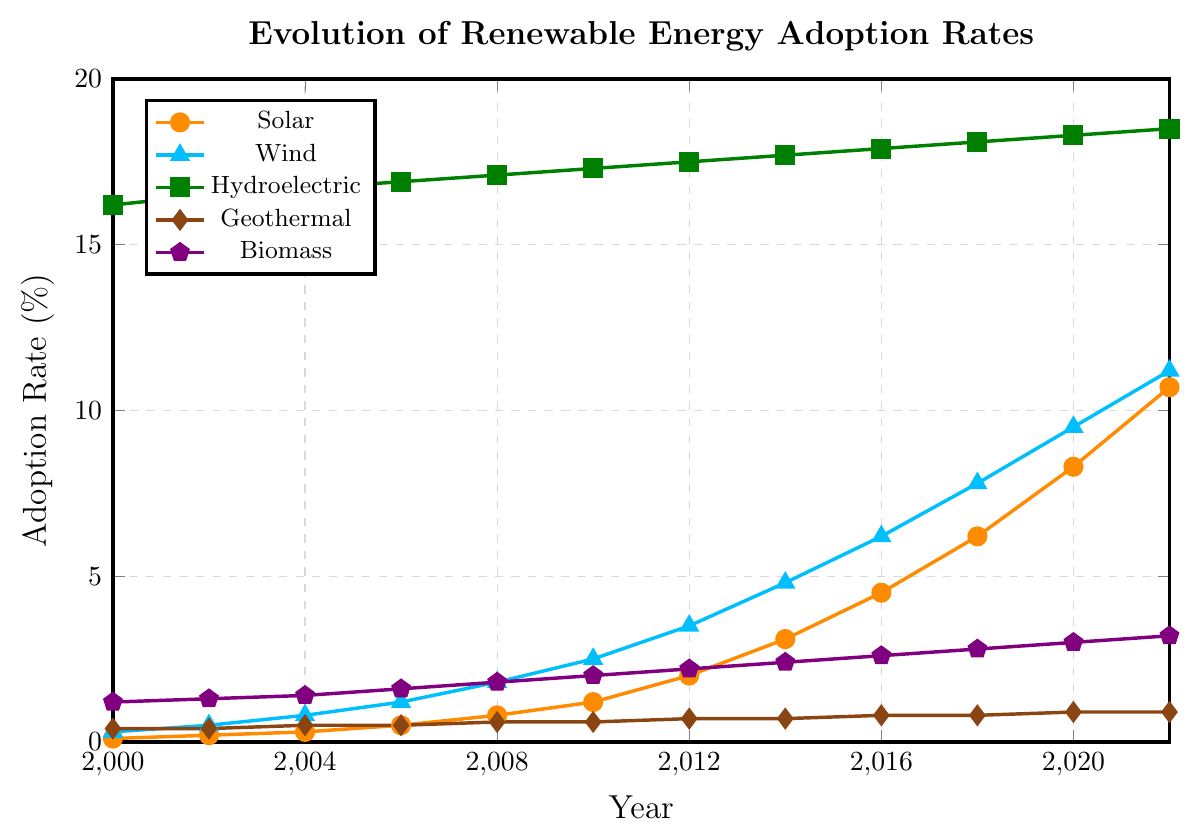What energy type had the highest adoption rate in the year 2022? Looking at the figure, the curve representing hydroelectric energy adoption is the highest among all the curves, surpassing solar, wind, geothermal, and biomass in the year 2022.
Answer: Hydroelectric What is the difference in adoption rate between solar and wind energy in 2020? From the figure, solar energy adoption in 2020 is 8.3%, and wind energy adoption is 9.5%. Subtracting the adoption rate of solar from wind gives 9.5% - 8.3% = 1.2%.
Answer: 1.2% Which energy type shows the most significant increase in adoption rate from 2000 to 2022? By comparing the curves from 2000 to 2022, the solar energy adoption rate increased from 0.1% to 10.7%, which is the most significant increase compared to the other energy types whose increases are proportionally smaller.
Answer: Solar How does the adoption rate of wind energy in 2016 compare to biomass energy in the same year? In 2016, the wind energy adoption rate is observed to be 6.2%, whereas biomass energy adoption is 2.6%. Therefore, wind energy adoption is higher than biomass energy adoption.
Answer: Wind energy is higher What is the average adoption rate of hydroelectric energy from 2000 to 2022? Examining the figure, the adoption rates of hydroelectric energy are (16.2, 16.5, 16.7, 16.9, 17.1, 17.3, 17.5, 17.7, 17.9, 18.1, 18.3, 18.5). Summing them up gives 213.7. Dividing by 12 (the number of points) gives an average of 213.7 / 12 ≈ 17.81%.
Answer: 17.81% Between which consecutive years did solar energy see the highest growth rate? To find the highest growth rate, we need to look at the increments between each consecutive year. Observing the figure, the most rapid increase appears between 2020 (8.3%) and 2022 (10.7%), which is a growth of 10.7 - 8.3 = 2.4%.
Answer: 2020 to 2022 What energy type had a stable adoption rate with minimal changes over the observed period? Geothermal energy shows an almost flat line across the timeline, with minimal increases from 0.4% to 0.9%, indicating very little variation.
Answer: Geothermal Sum the adoption rates of biomass energy in 2000, 2010, and 2022. Biomass energy adoption rates in these years are 1.2%, 2.0%, and 3.2%, respectively. Summing them, we get 1.2 + 2.0 + 3.2 = 6.4%.
Answer: 6.4% Compare the adoption rates of all energy types in 2002 and determine which has the lowest adoption rate in that year. In 2002, the adoption rates are: Solar (0.2%), Wind (0.5%), Hydroelectric (16.5%), Geothermal (0.4%), Biomass (1.3%). Among these, solar has the lowest adoption rate at 0.2%.
Answer: Solar 